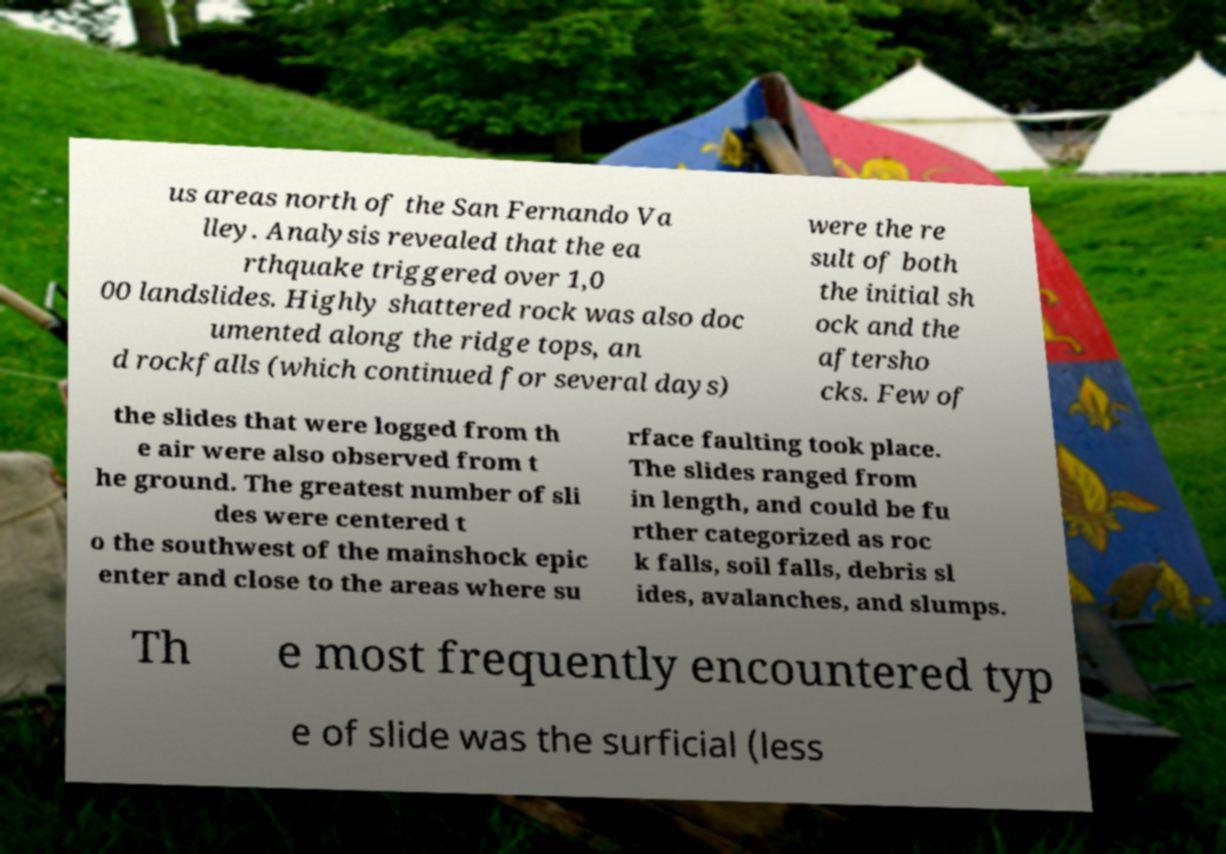Could you assist in decoding the text presented in this image and type it out clearly? us areas north of the San Fernando Va lley. Analysis revealed that the ea rthquake triggered over 1,0 00 landslides. Highly shattered rock was also doc umented along the ridge tops, an d rockfalls (which continued for several days) were the re sult of both the initial sh ock and the aftersho cks. Few of the slides that were logged from th e air were also observed from t he ground. The greatest number of sli des were centered t o the southwest of the mainshock epic enter and close to the areas where su rface faulting took place. The slides ranged from in length, and could be fu rther categorized as roc k falls, soil falls, debris sl ides, avalanches, and slumps. Th e most frequently encountered typ e of slide was the surficial (less 